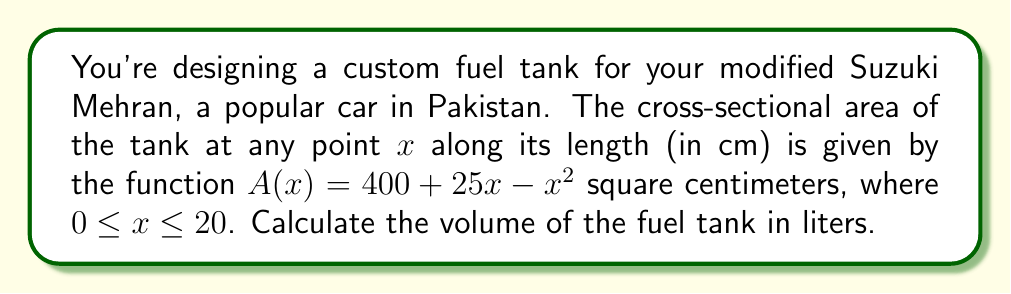Teach me how to tackle this problem. To find the volume of the fuel tank, we need to integrate the cross-sectional area function over the length of the tank. Here's how we do it:

1) The volume of a solid with a variable cross-sectional area is given by the integral:

   $$V = \int_a^b A(x) dx$$

   where $A(x)$ is the cross-sectional area function, and $a$ and $b$ are the limits of integration.

2) In this case, $A(x) = 400 + 25x - x^2$, $a = 0$, and $b = 20$. So we have:

   $$V = \int_0^{20} (400 + 25x - x^2) dx$$

3) Let's integrate this function:

   $$V = [400x + \frac{25x^2}{2} - \frac{x^3}{3}]_0^{20}$$

4) Now, let's evaluate this at the limits:

   $$V = (400(20) + \frac{25(20^2)}{2} - \frac{20^3}{3}) - (400(0) + \frac{25(0^2)}{2} - \frac{0^3}{3})$$

5) Simplify:

   $$V = (8000 + 5000 - \frac{8000}{3}) - 0 = 13000 - \frac{8000}{3} = \frac{31000}{3} \text{ cm}^3$$

6) Convert cubic centimeters to liters:

   $$\frac{31000}{3} \text{ cm}^3 = \frac{31000}{3000} \text{ L} = \frac{31}{3} \text{ L} \approx 10.33 \text{ L}$$

Thus, the volume of the fuel tank is approximately 10.33 liters.
Answer: 10.33 L 